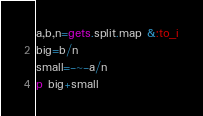<code> <loc_0><loc_0><loc_500><loc_500><_Ruby_>a,b,n=gets.split.map &:to_i
big=b/n
small=-~-a/n
p big+small</code> 